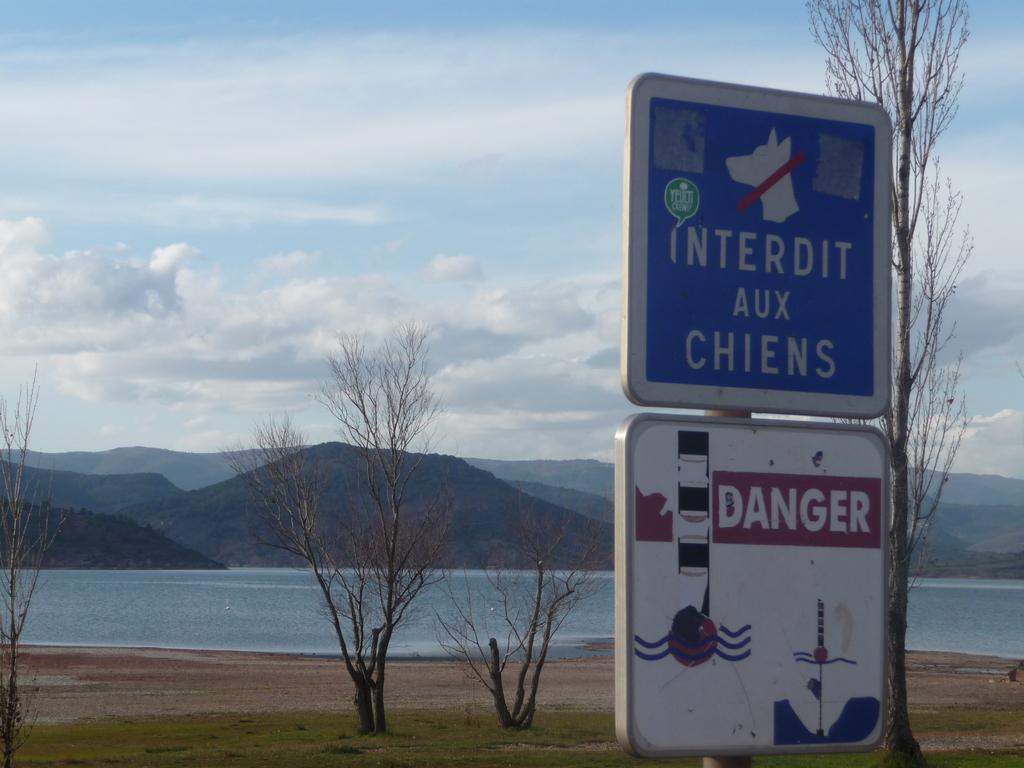What type of structures can be seen in the image? There are sign boards in the image. What can be seen on the ground in the image? The ground is visible in the image. What type of vegetation is present in the image? There is grass in the image, and dry trees are also present. What natural features can be seen in the image? Water, mountains, and the sky are visible in the image. What is the condition of the sky in the image? Clouds are present in the sky. What is the opinion of the snails about the water in the image? There are no snails present in the image, so it is not possible to determine their opinion about the water. 